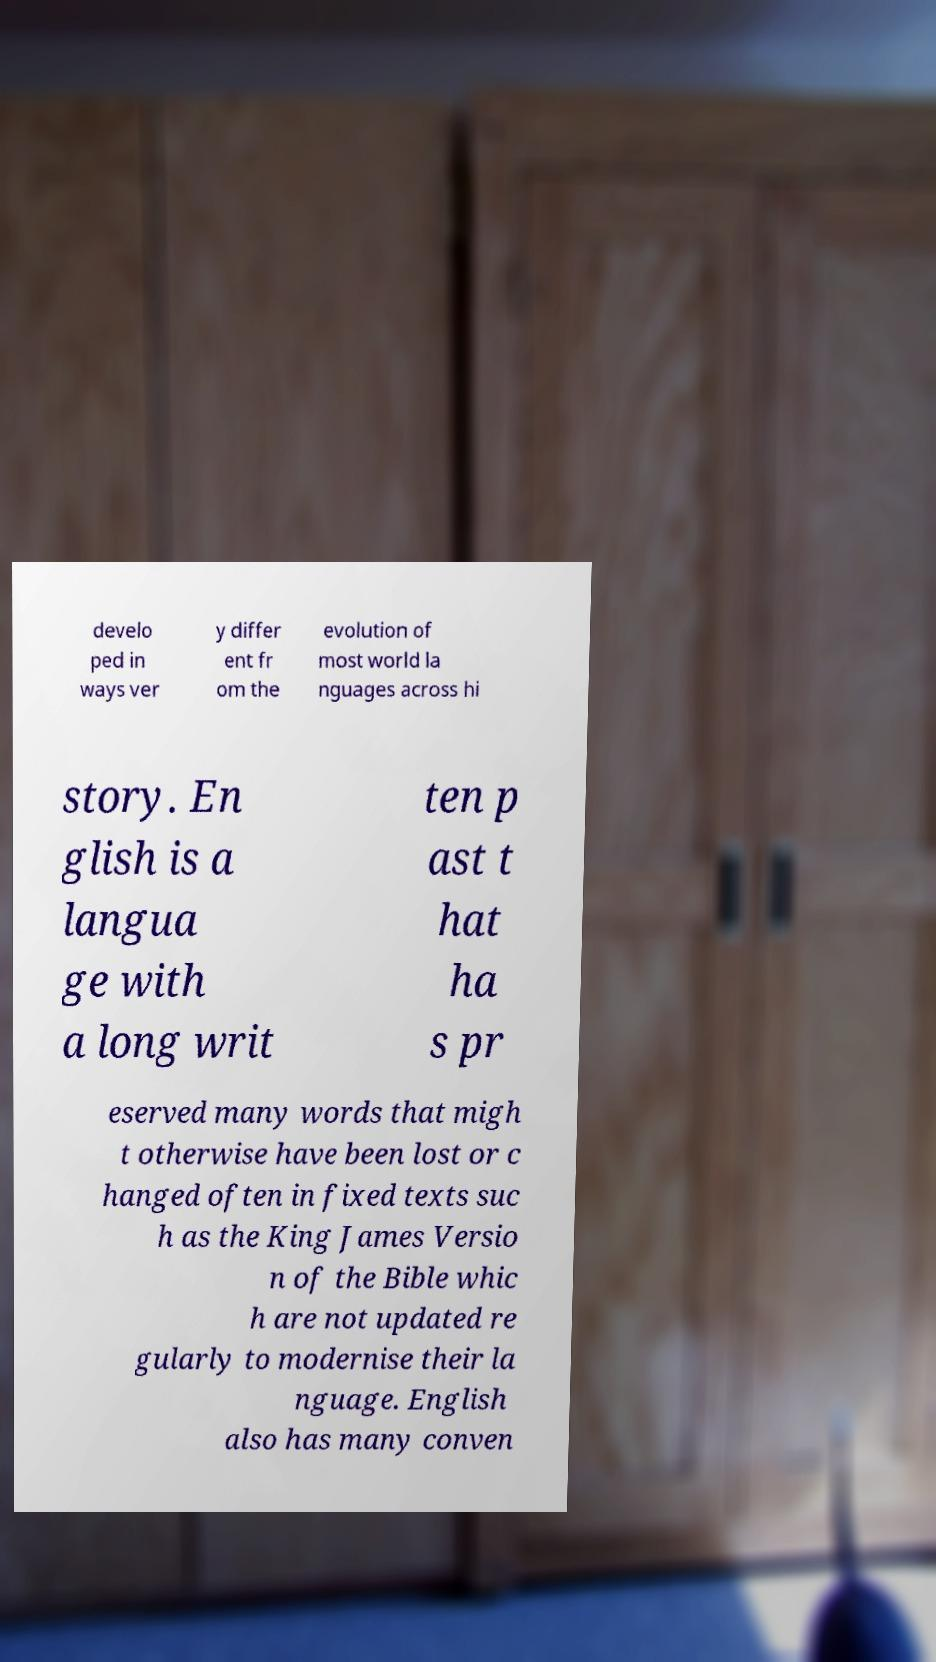For documentation purposes, I need the text within this image transcribed. Could you provide that? develo ped in ways ver y differ ent fr om the evolution of most world la nguages across hi story. En glish is a langua ge with a long writ ten p ast t hat ha s pr eserved many words that migh t otherwise have been lost or c hanged often in fixed texts suc h as the King James Versio n of the Bible whic h are not updated re gularly to modernise their la nguage. English also has many conven 